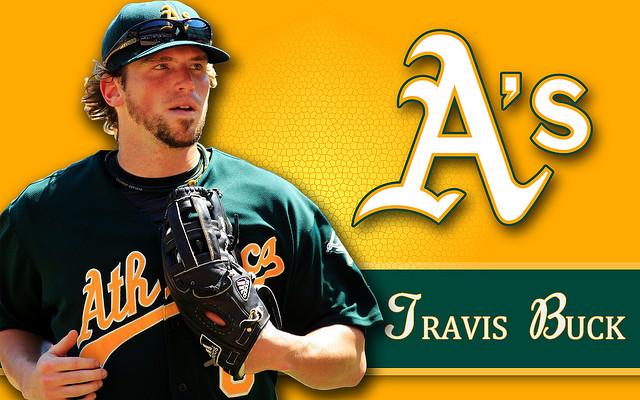Which state is this baseball team from?
Quick response, please. California. Is this man a famous player?
Write a very short answer. Yes. What sport does this man play?
Quick response, please. Baseball. 